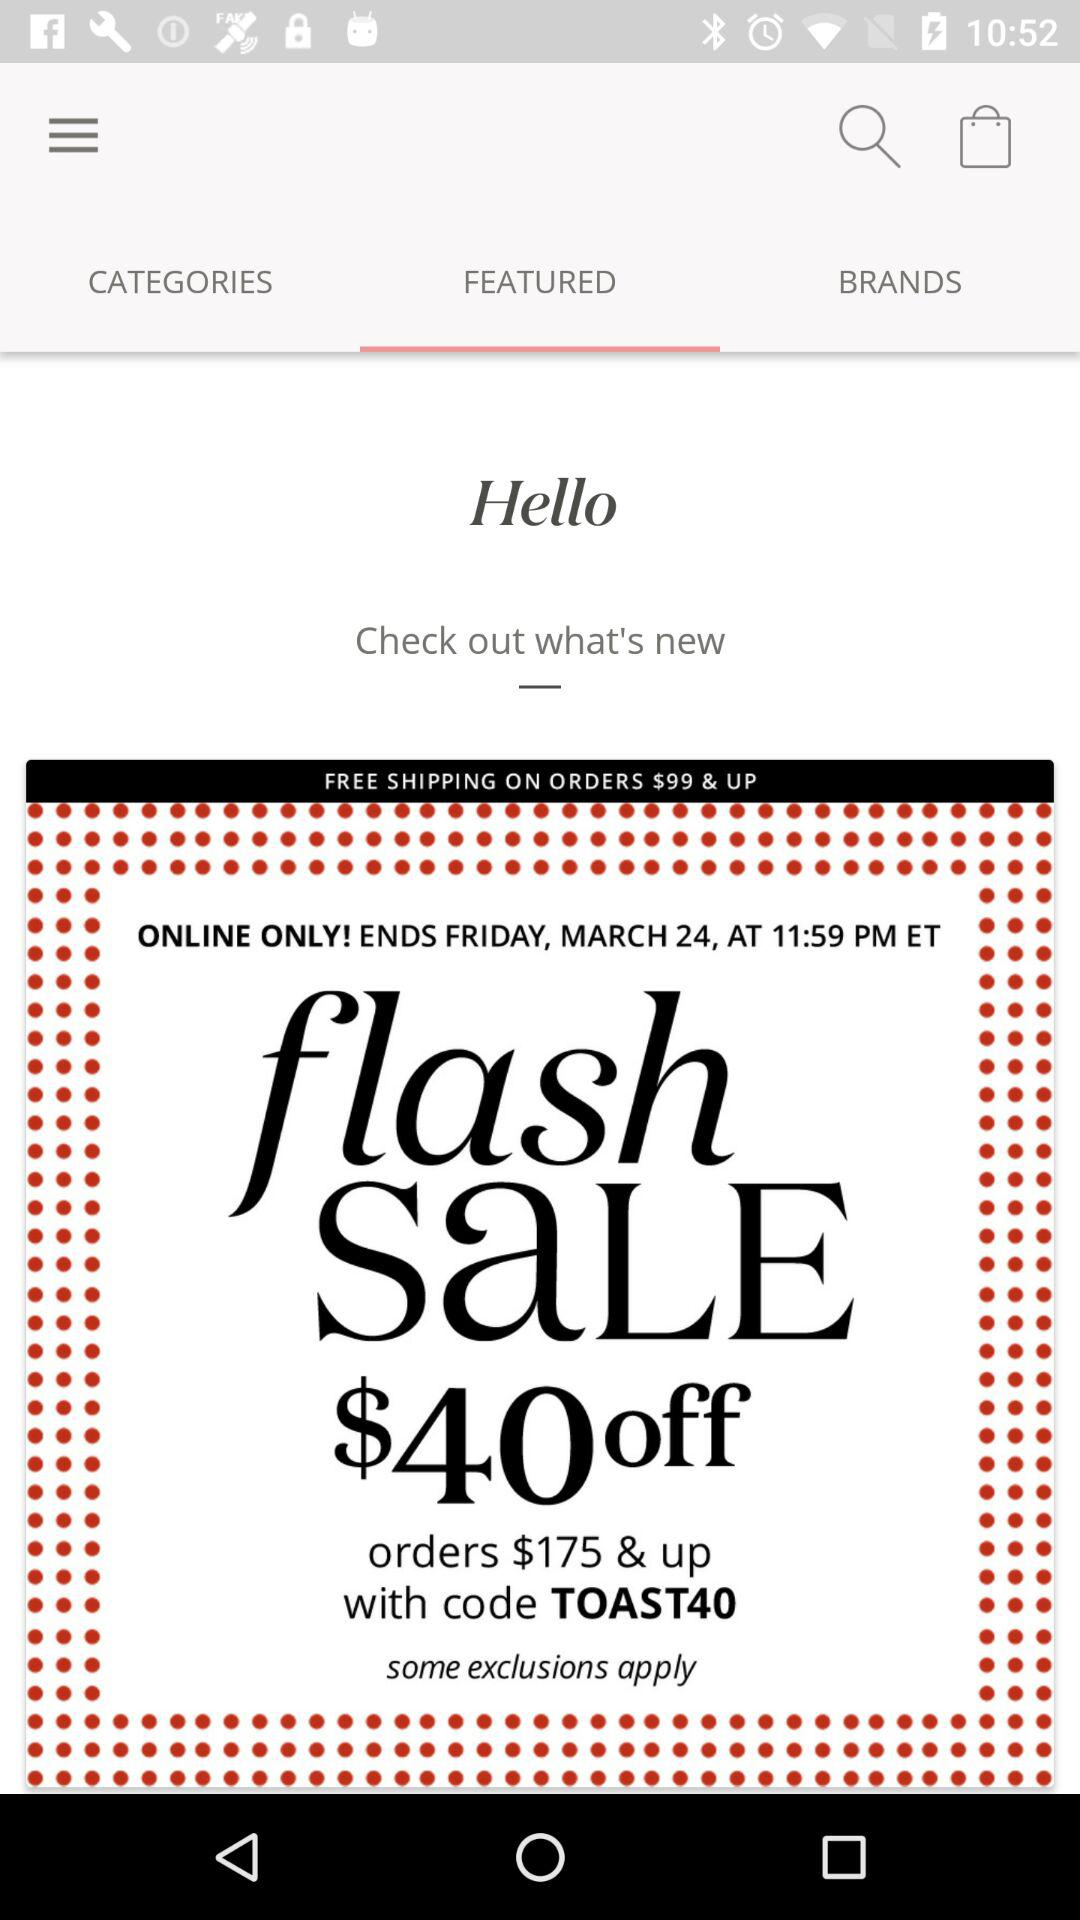What is the code for flash sales? The code is TOAST40. 